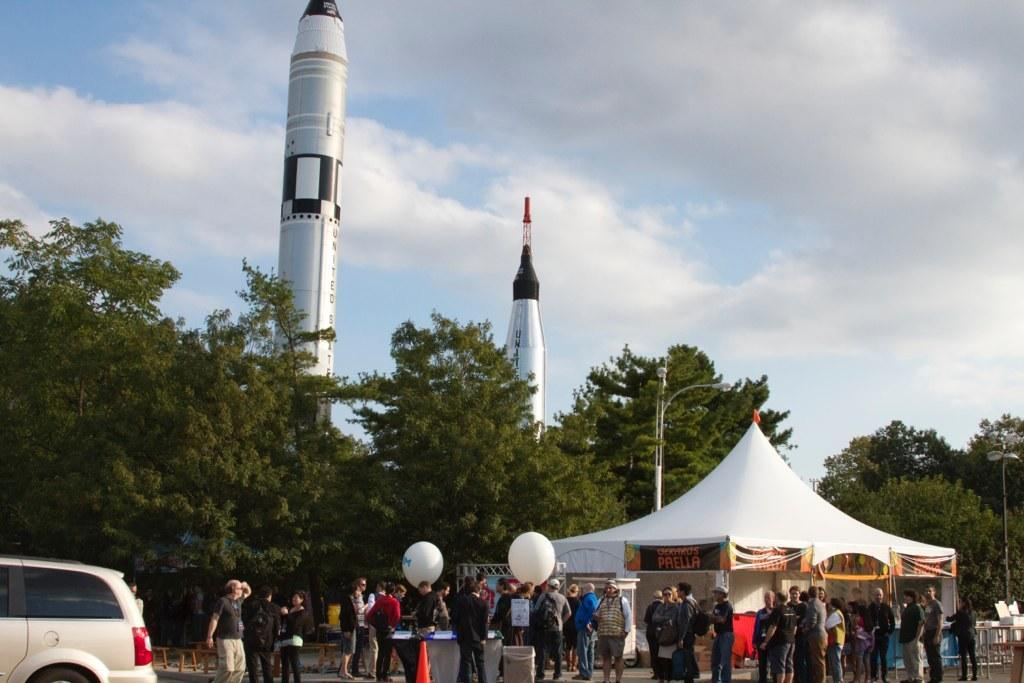What can be seen in the image that resembles a vehicle? There is a car parked in the image. What are the main subjects in the image? There are two rockets in the image. What is located in front of the rockets? There are trees in front of the rockets. What is situated in front of the trees? There are tents in front of the trees. What is present in front of the tents? There are people standing in front of the tents. What type of stew is being served in the image? There is no stew present in the image. What is the condition of the people's throats in the image? There is no information about the people's throats in the image. 